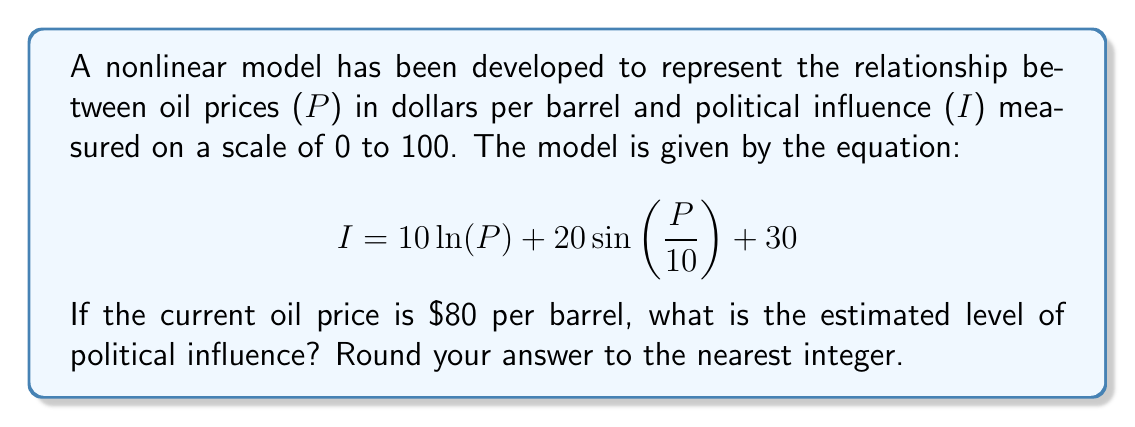Teach me how to tackle this problem. To solve this problem, we need to follow these steps:

1) We are given that P = 80 (current oil price in dollars per barrel).

2) We need to substitute this value into the equation:

   $$ I = 10 \ln(P) + 20\sin(\frac{P}{10}) + 30 $$

3) Let's calculate each term separately:

   a) $10 \ln(P) = 10 \ln(80) \approx 43.82$

   b) $20\sin(\frac{P}{10}) = 20\sin(\frac{80}{10}) = 20\sin(8) \approx 19.86$

   c) The constant term is 30

4) Now, let's sum up all these terms:

   $$ I = 43.82 + 19.86 + 30 = 93.68 $$

5) Rounding to the nearest integer:

   $$ I \approx 94 $$
Answer: 94 